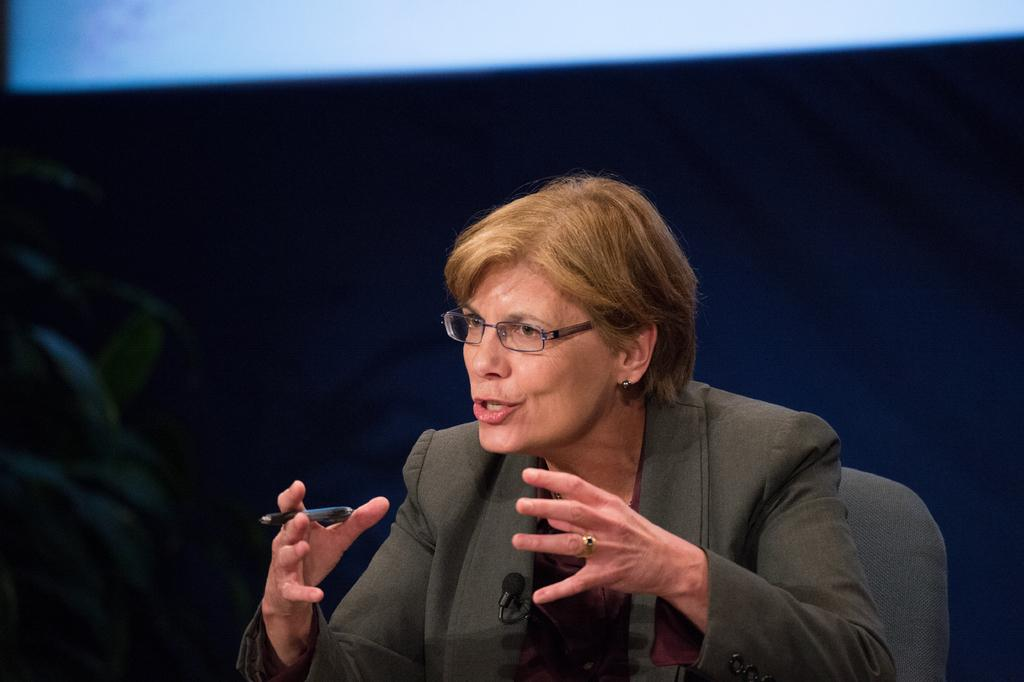Who is the main subject in the image? There is a woman in the image. What is the woman holding in the image? The woman is holding a pen. What is the woman doing in the image? The woman is explaining something. Can you describe any additional features of the woman in the image? There is a microphone on her jacket. What type of wool is being used to measure the distance to the moon in the image? There is no wool or measurement of the distance to the moon present in the image. 